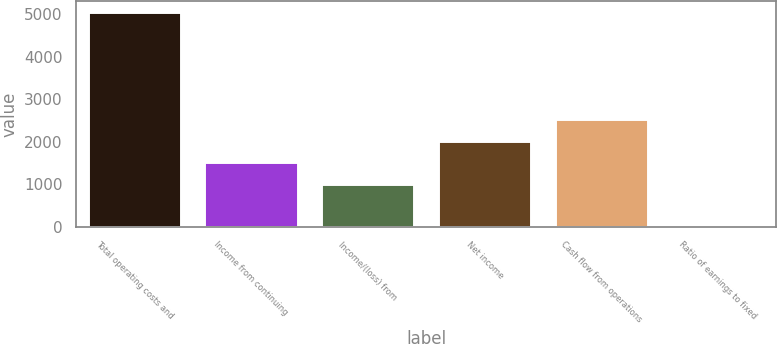Convert chart. <chart><loc_0><loc_0><loc_500><loc_500><bar_chart><fcel>Total operating costs and<fcel>Income from continuing<fcel>Income/(loss) from<fcel>Net income<fcel>Cash flow from operations<fcel>Ratio of earnings to fixed<nl><fcel>5060<fcel>1519.43<fcel>1013.63<fcel>2025.23<fcel>2531.03<fcel>2.03<nl></chart> 